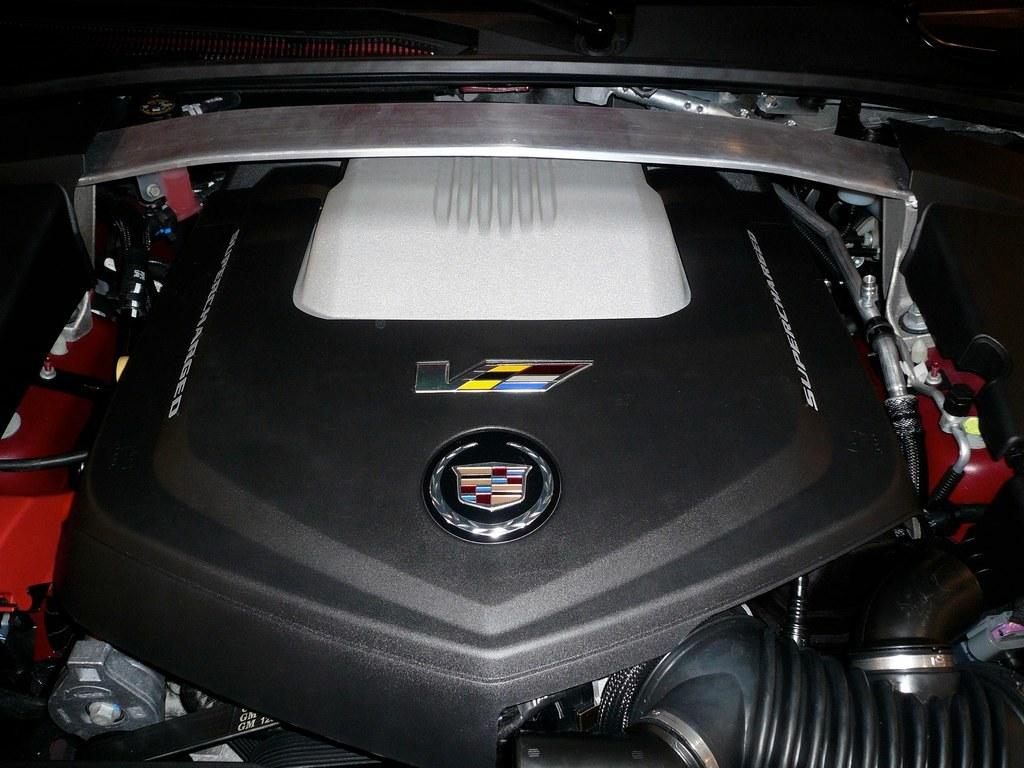What type of location is depicted in the image? The image is of the inside part of a vehicle. Can you tell me how many squirrels are sitting on the dashboard in the image? There are no squirrels present in the image; it depicts the inside part of a vehicle. 